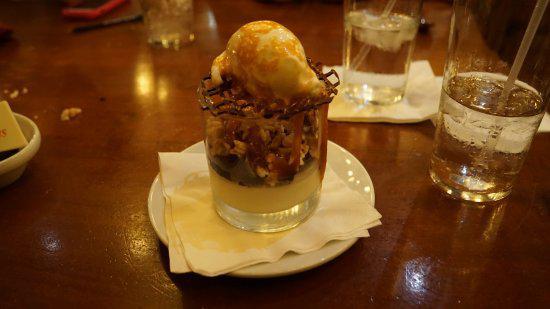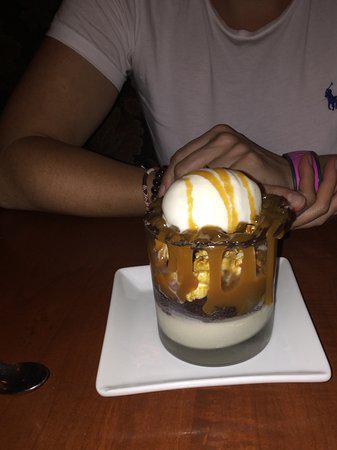The first image is the image on the left, the second image is the image on the right. Given the left and right images, does the statement "1 of the images has 1 candle in the background." hold true? Answer yes or no. No. 